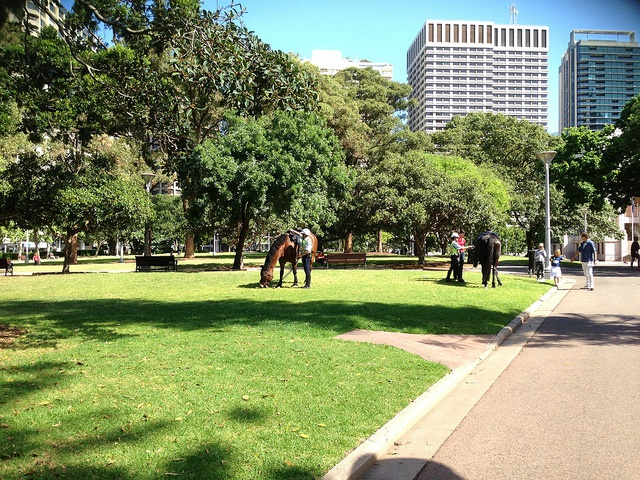Describe the objects in this image and their specific colors. I can see horse in black, maroon, brown, and gray tones, horse in black, gray, maroon, and darkgray tones, people in black, darkgray, white, and gray tones, bench in black, gray, darkgreen, and olive tones, and people in black, white, gray, and olive tones in this image. 